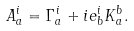<formula> <loc_0><loc_0><loc_500><loc_500>A _ { a } ^ { i } = \Gamma _ { a } ^ { i } + i e _ { b } ^ { i } K _ { a } ^ { b } .</formula> 